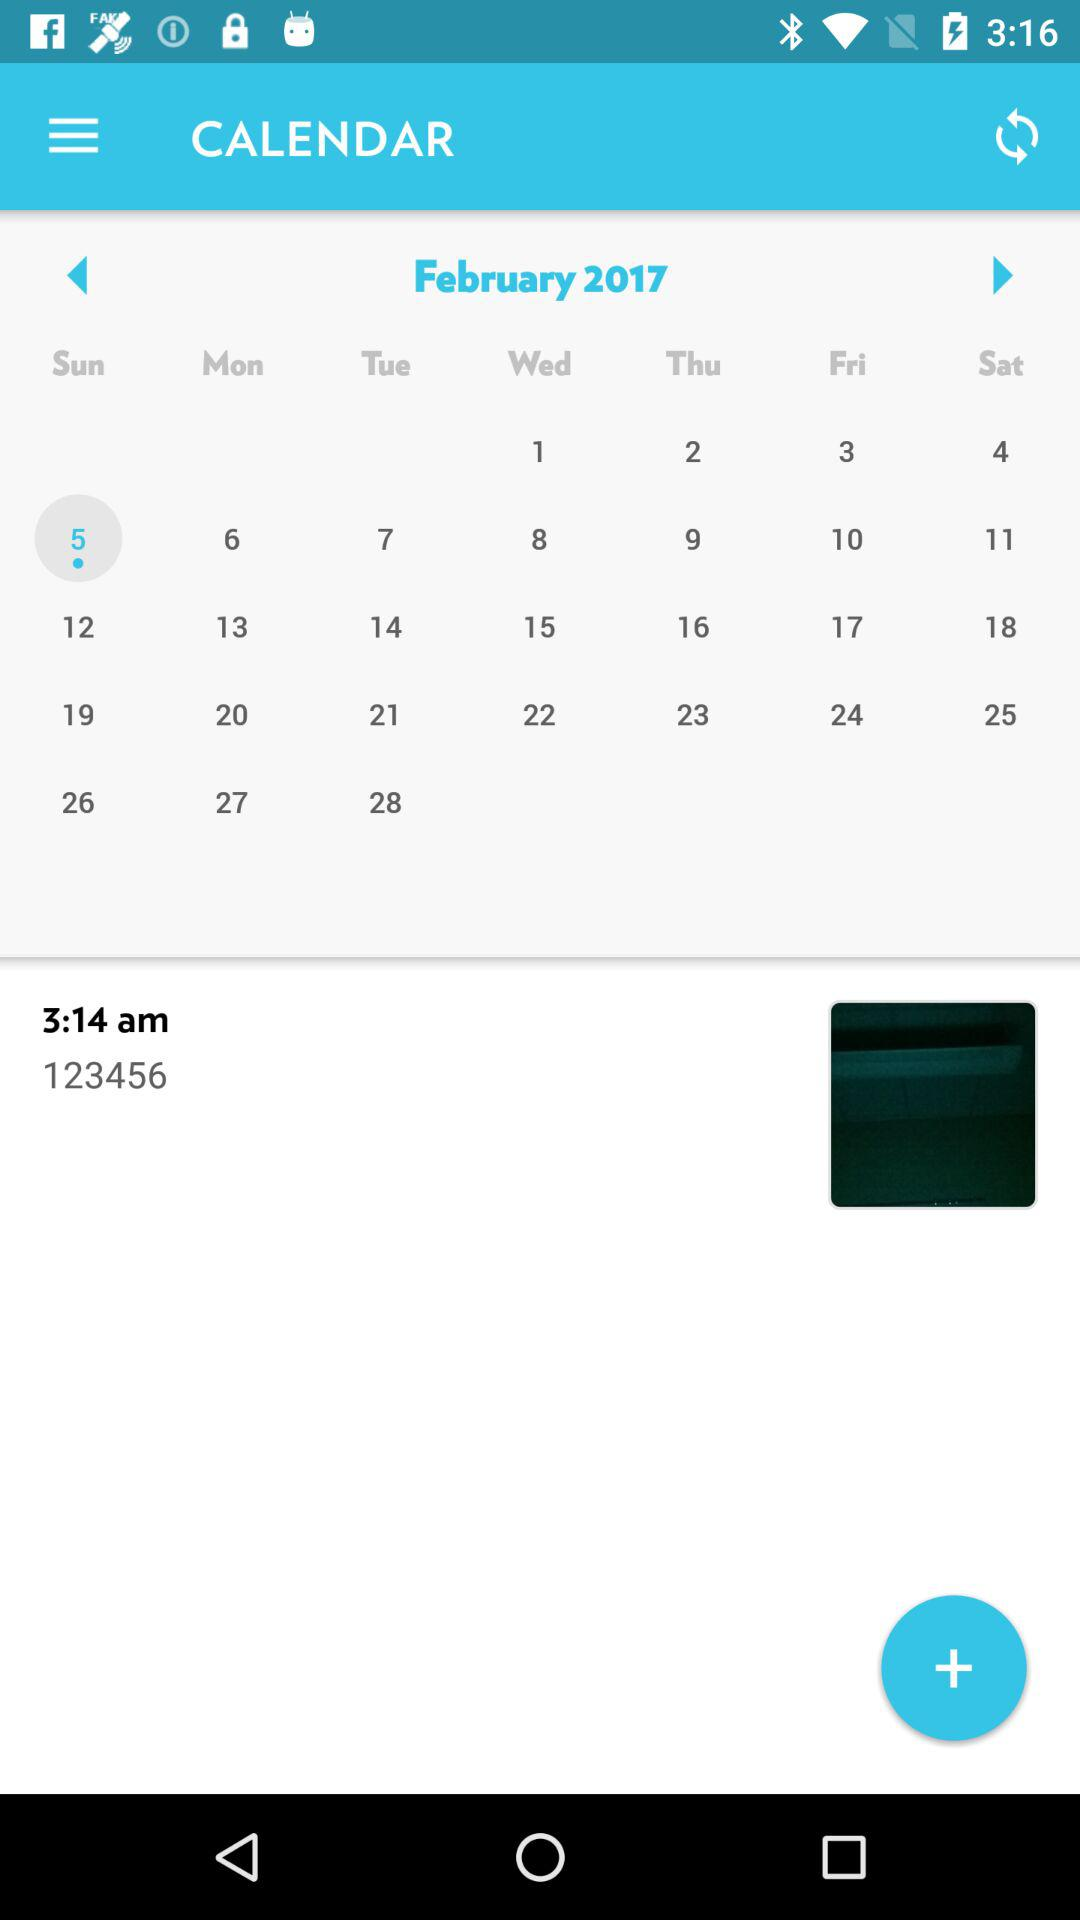At what time was the note added? The note was added at 3:14 a.m. 